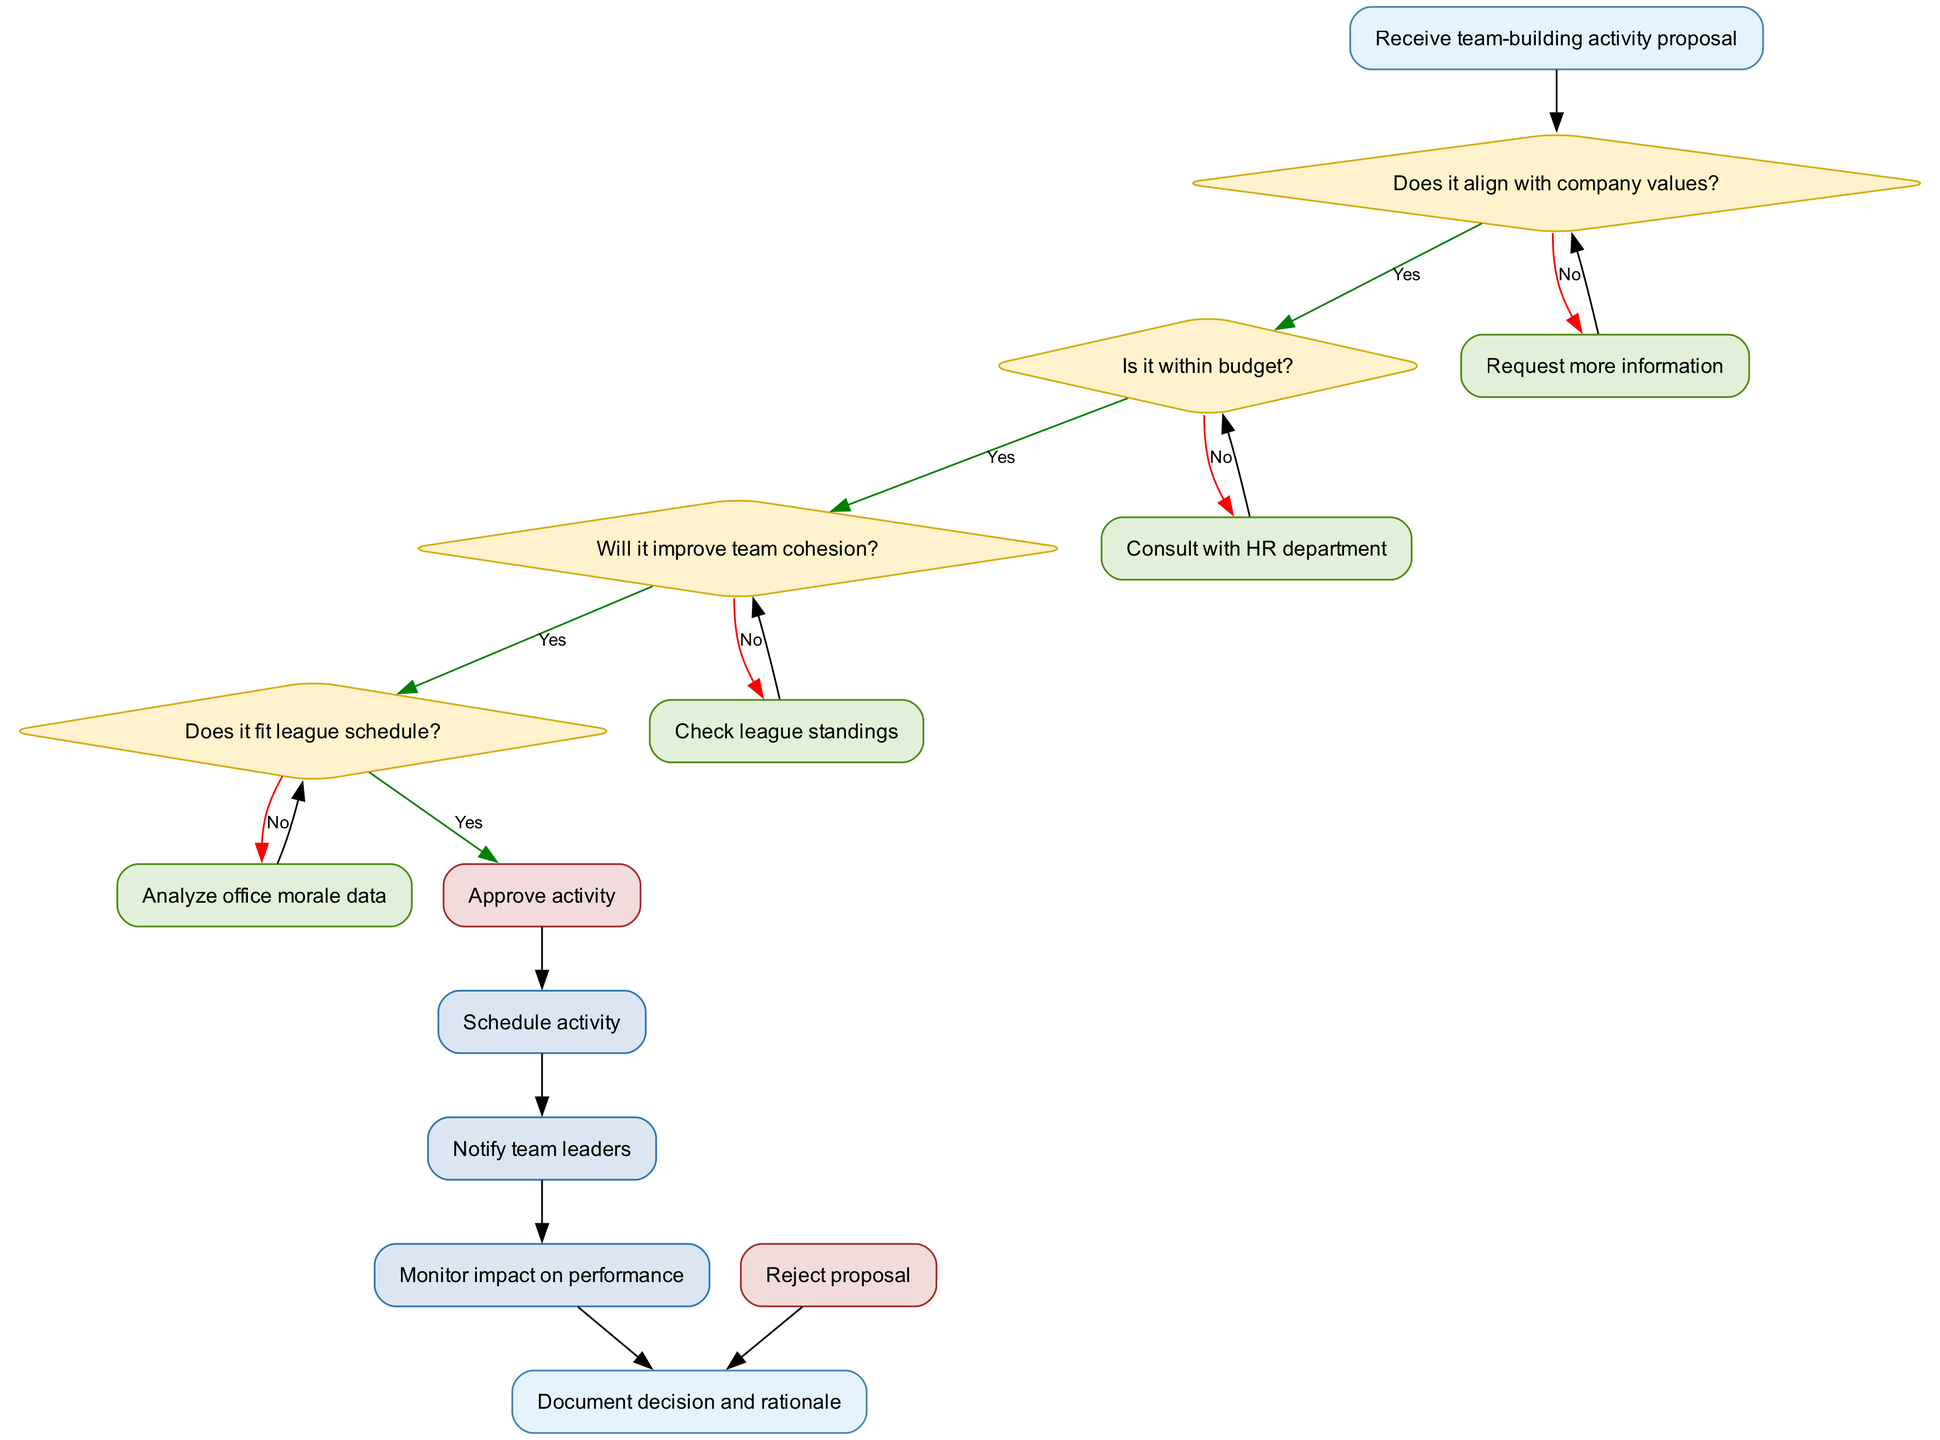What is the first step in the workflow? The first step, represented by the start node, is "Receive team-building activity proposal." It leads directly into the decision-making process.
Answer: Receive team-building activity proposal How many decision points are there in this workflow? By counting the nodes represented as diamonds, there are four decision points in total.
Answer: 4 What action follows if the proposal does not align with company values? If the proposal does not align with company values, the action taken is "Request more information," as indicated by the edge labeled "No" going to that action node.
Answer: Request more information What happens if the proposal fits the league schedule? If the proposal fits the league schedule, it leads to the approval decision, allowing the workflow to proceed to "Approve activity." This is indicated by the edge labeled "Yes."
Answer: Approve activity What is the final step after documenting the decision? After documenting the decision and rationale, the workflow concludes, marking the end of the process. This is represented as the final node in the diagram.
Answer: Document decision and rationale 